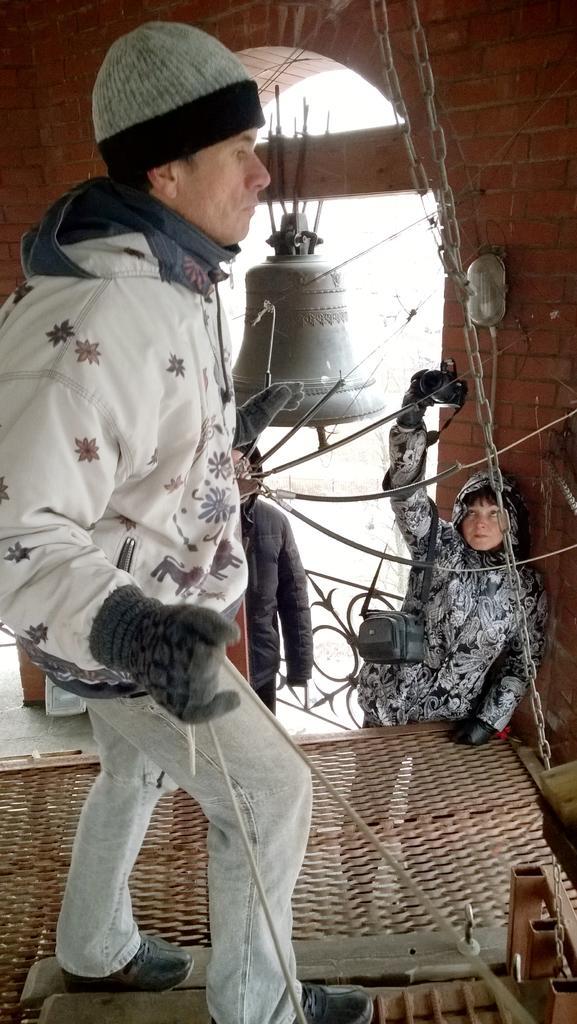How would you summarize this image in a sentence or two? In this image there is a person standing on the object, which is connected to chains, behind the person there are two people standing on the floor and there is a bell hanging on the wall. 